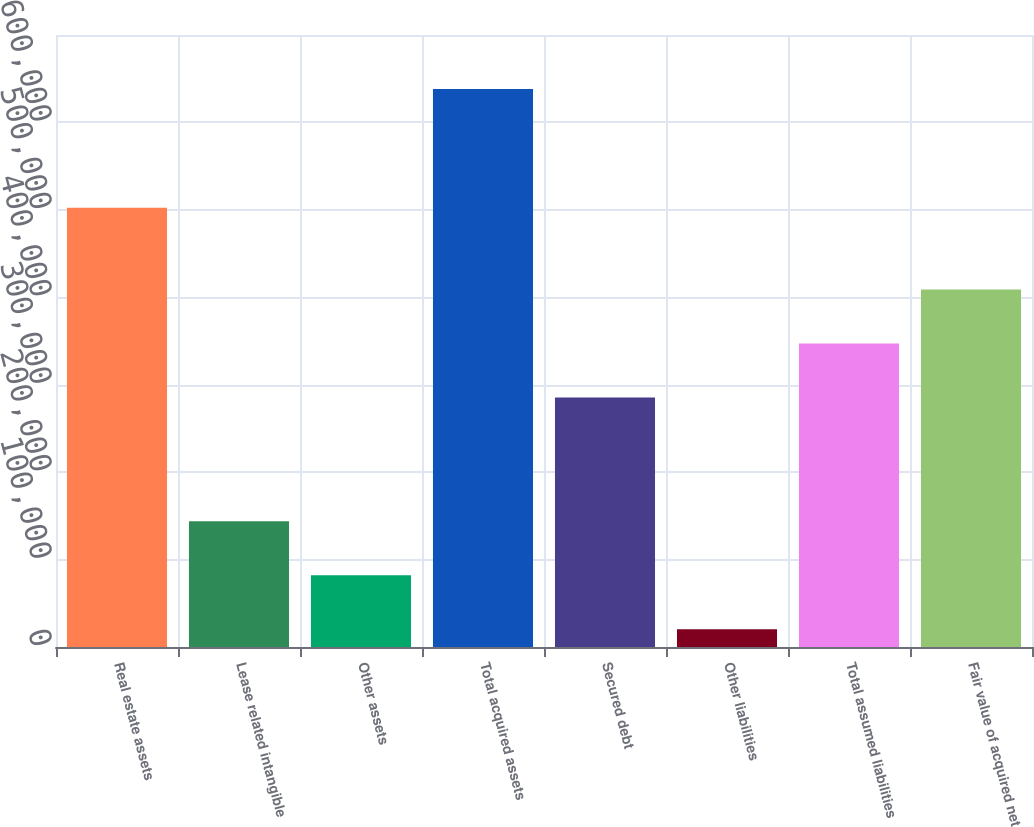<chart> <loc_0><loc_0><loc_500><loc_500><bar_chart><fcel>Real estate assets<fcel>Lease related intangible<fcel>Other assets<fcel>Total acquired assets<fcel>Secured debt<fcel>Other liabilities<fcel>Total assumed liabilities<fcel>Fair value of acquired net<nl><fcel>502418<fcel>143841<fcel>82041.8<fcel>638231<fcel>285376<fcel>20243<fcel>347175<fcel>408974<nl></chart> 